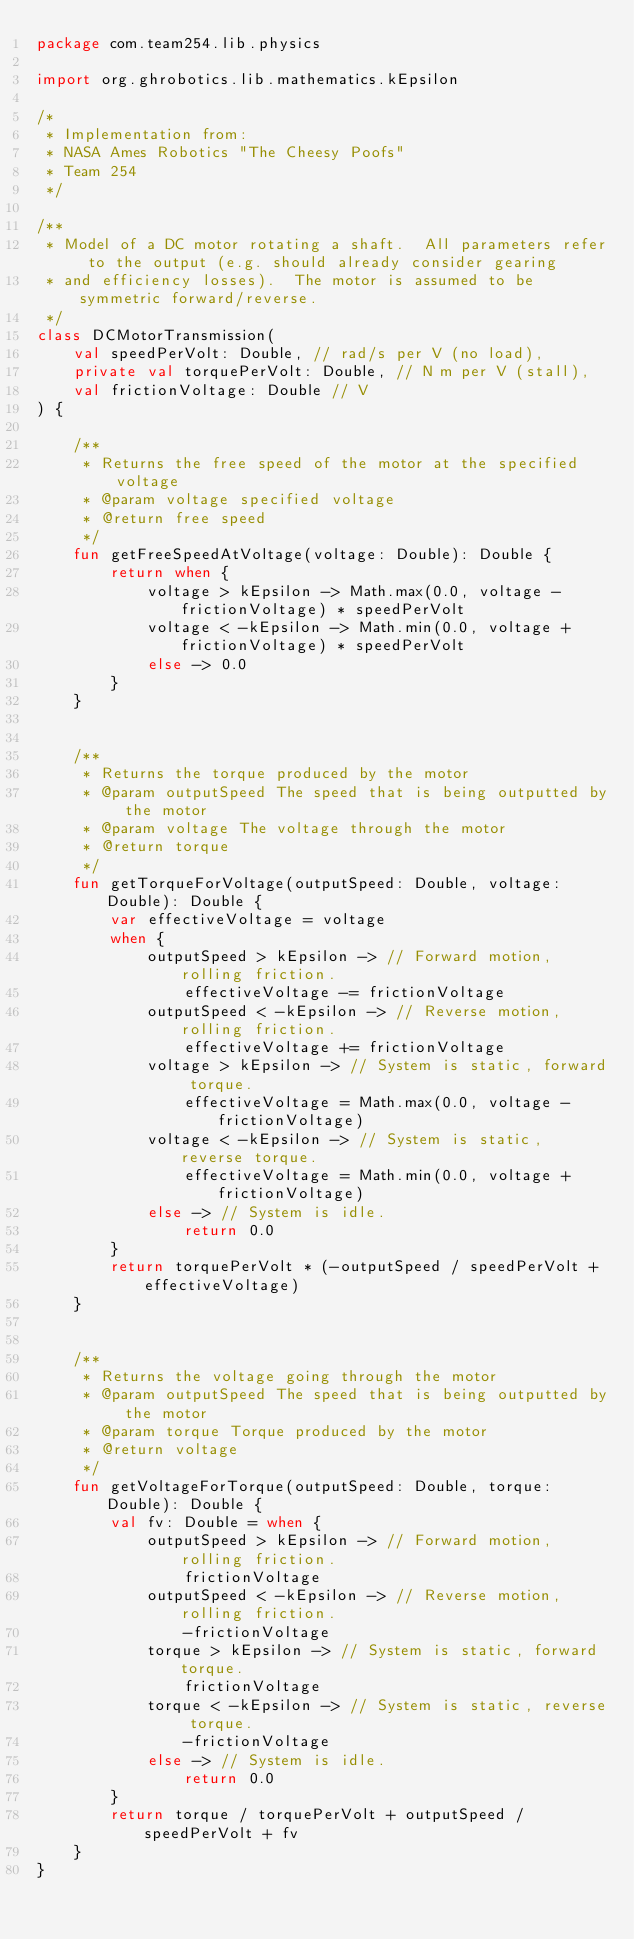Convert code to text. <code><loc_0><loc_0><loc_500><loc_500><_Kotlin_>package com.team254.lib.physics

import org.ghrobotics.lib.mathematics.kEpsilon

/*
 * Implementation from:
 * NASA Ames Robotics "The Cheesy Poofs"
 * Team 254
 */

/**
 * Model of a DC motor rotating a shaft.  All parameters refer to the output (e.g. should already consider gearing
 * and efficiency losses).  The motor is assumed to be symmetric forward/reverse.
 */
class DCMotorTransmission(
    val speedPerVolt: Double, // rad/s per V (no load),
    private val torquePerVolt: Double, // N m per V (stall),
    val frictionVoltage: Double // V
) {

    /**
     * Returns the free speed of the motor at the specified voltage
     * @param voltage specified voltage
     * @return free speed
     */
    fun getFreeSpeedAtVoltage(voltage: Double): Double {
        return when {
            voltage > kEpsilon -> Math.max(0.0, voltage - frictionVoltage) * speedPerVolt
            voltage < -kEpsilon -> Math.min(0.0, voltage + frictionVoltage) * speedPerVolt
            else -> 0.0
        }
    }


    /**
     * Returns the torque produced by the motor
     * @param outputSpeed The speed that is being outputted by the motor
     * @param voltage The voltage through the motor
     * @return torque
     */
    fun getTorqueForVoltage(outputSpeed: Double, voltage: Double): Double {
        var effectiveVoltage = voltage
        when {
            outputSpeed > kEpsilon -> // Forward motion, rolling friction.
                effectiveVoltage -= frictionVoltage
            outputSpeed < -kEpsilon -> // Reverse motion, rolling friction.
                effectiveVoltage += frictionVoltage
            voltage > kEpsilon -> // System is static, forward torque.
                effectiveVoltage = Math.max(0.0, voltage - frictionVoltage)
            voltage < -kEpsilon -> // System is static, reverse torque.
                effectiveVoltage = Math.min(0.0, voltage + frictionVoltage)
            else -> // System is idle.
                return 0.0
        }
        return torquePerVolt * (-outputSpeed / speedPerVolt + effectiveVoltage)
    }


    /**
     * Returns the voltage going through the motor
     * @param outputSpeed The speed that is being outputted by the motor
     * @param torque Torque produced by the motor
     * @return voltage
     */
    fun getVoltageForTorque(outputSpeed: Double, torque: Double): Double {
        val fv: Double = when {
            outputSpeed > kEpsilon -> // Forward motion, rolling friction.
                frictionVoltage
            outputSpeed < -kEpsilon -> // Reverse motion, rolling friction.
                -frictionVoltage
            torque > kEpsilon -> // System is static, forward torque.
                frictionVoltage
            torque < -kEpsilon -> // System is static, reverse torque.
                -frictionVoltage
            else -> // System is idle.
                return 0.0
        }
        return torque / torquePerVolt + outputSpeed / speedPerVolt + fv
    }
}
</code> 